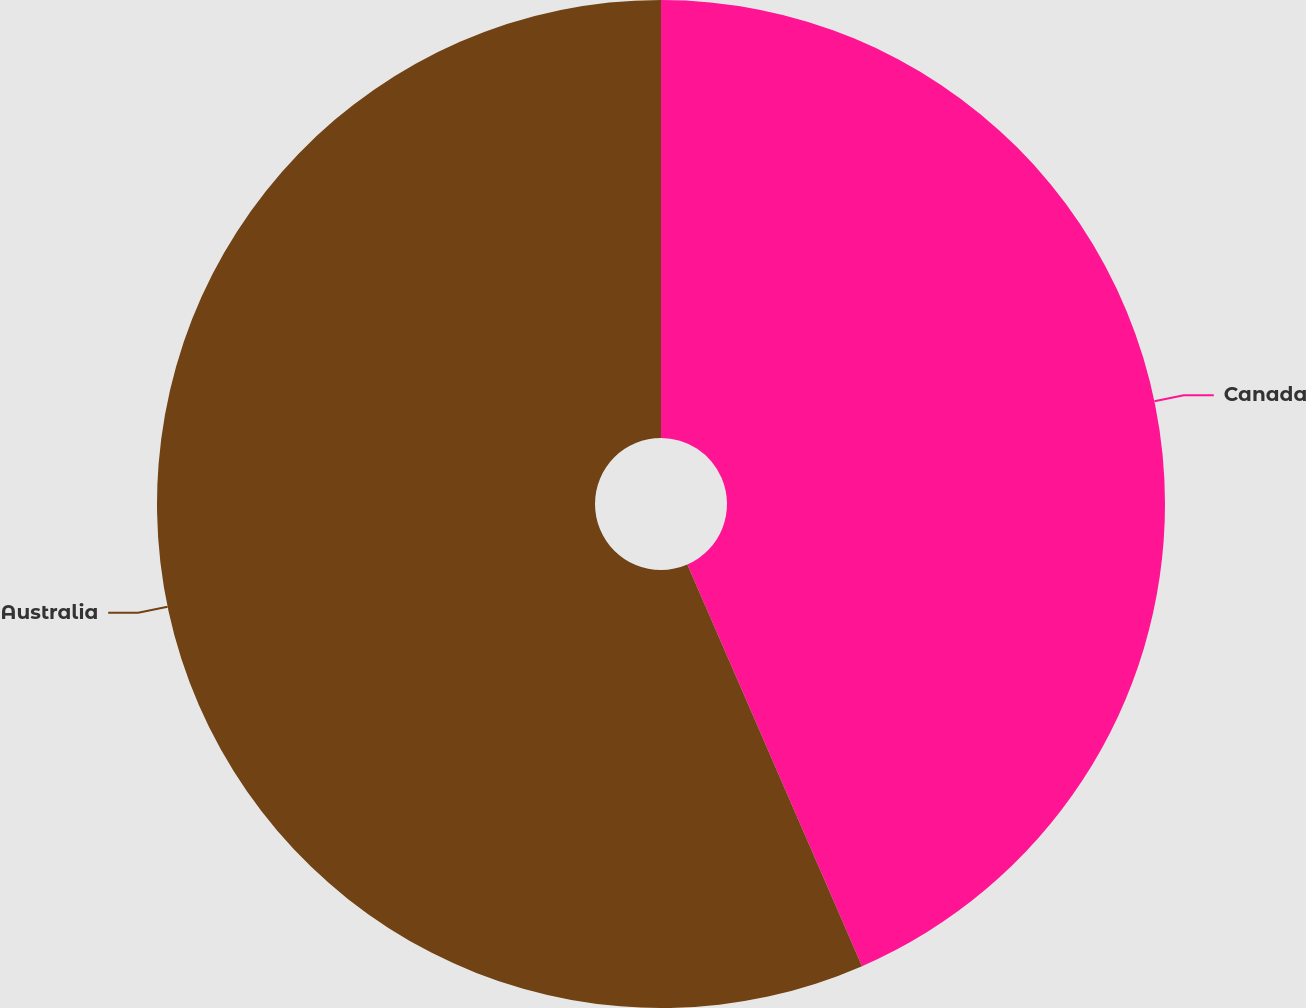<chart> <loc_0><loc_0><loc_500><loc_500><pie_chart><fcel>Canada<fcel>Australia<nl><fcel>43.47%<fcel>56.53%<nl></chart> 